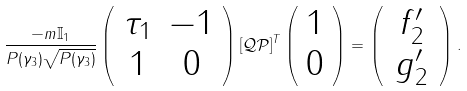Convert formula to latex. <formula><loc_0><loc_0><loc_500><loc_500>\frac { - m \mathbb { I } _ { 1 } } { P ( \gamma _ { 3 } ) \sqrt { P ( \gamma _ { 3 } ) } } \left ( \begin{array} { c c } \tau _ { 1 } & - 1 \\ 1 & 0 \end{array} \right ) [ \mathcal { Q P } ] ^ { T } \left ( \begin{array} { c } 1 \\ 0 \end{array} \right ) = \left ( \, \begin{array} { c } f ^ { \prime } _ { 2 } \\ g ^ { \prime } _ { 2 } \end{array} \, \right ) .</formula> 